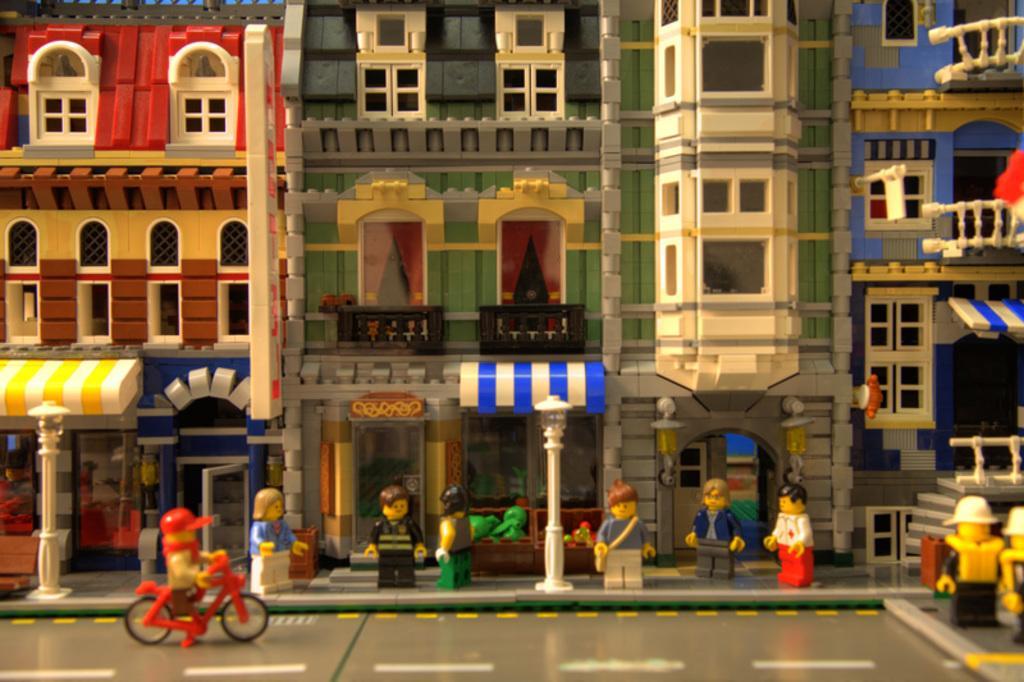Describe this image in one or two sentences. This picture consists of lego in the image, which contains toy buildings and toy people at the bottom side of the image. 